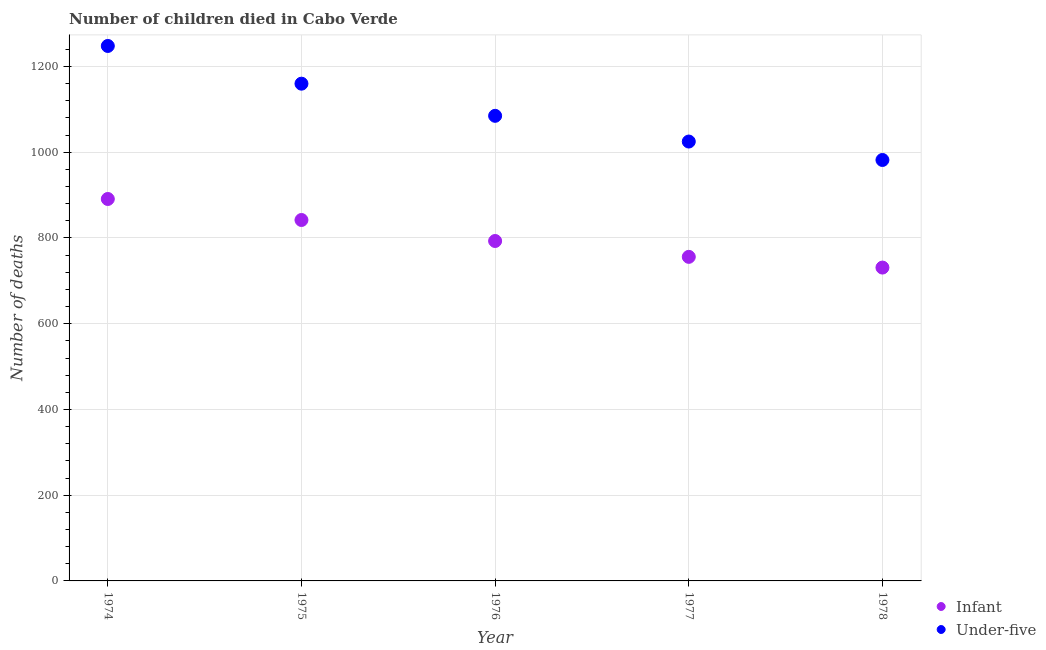How many different coloured dotlines are there?
Make the answer very short. 2. Is the number of dotlines equal to the number of legend labels?
Make the answer very short. Yes. What is the number of under-five deaths in 1976?
Give a very brief answer. 1085. Across all years, what is the maximum number of infant deaths?
Keep it short and to the point. 891. Across all years, what is the minimum number of under-five deaths?
Give a very brief answer. 982. In which year was the number of infant deaths maximum?
Ensure brevity in your answer.  1974. In which year was the number of under-five deaths minimum?
Give a very brief answer. 1978. What is the total number of infant deaths in the graph?
Provide a succinct answer. 4013. What is the difference between the number of infant deaths in 1975 and that in 1976?
Ensure brevity in your answer.  49. What is the difference between the number of under-five deaths in 1978 and the number of infant deaths in 1976?
Make the answer very short. 189. What is the average number of under-five deaths per year?
Give a very brief answer. 1100. In the year 1975, what is the difference between the number of infant deaths and number of under-five deaths?
Offer a terse response. -318. What is the ratio of the number of under-five deaths in 1975 to that in 1978?
Make the answer very short. 1.18. What is the difference between the highest and the second highest number of infant deaths?
Offer a very short reply. 49. What is the difference between the highest and the lowest number of infant deaths?
Offer a very short reply. 160. Does the number of infant deaths monotonically increase over the years?
Your response must be concise. No. Is the number of under-five deaths strictly greater than the number of infant deaths over the years?
Provide a short and direct response. Yes. How many dotlines are there?
Ensure brevity in your answer.  2. How many years are there in the graph?
Your answer should be compact. 5. What is the difference between two consecutive major ticks on the Y-axis?
Ensure brevity in your answer.  200. Are the values on the major ticks of Y-axis written in scientific E-notation?
Give a very brief answer. No. Does the graph contain any zero values?
Make the answer very short. No. Does the graph contain grids?
Offer a terse response. Yes. What is the title of the graph?
Provide a short and direct response. Number of children died in Cabo Verde. What is the label or title of the Y-axis?
Make the answer very short. Number of deaths. What is the Number of deaths of Infant in 1974?
Offer a terse response. 891. What is the Number of deaths of Under-five in 1974?
Your answer should be compact. 1248. What is the Number of deaths in Infant in 1975?
Ensure brevity in your answer.  842. What is the Number of deaths in Under-five in 1975?
Ensure brevity in your answer.  1160. What is the Number of deaths in Infant in 1976?
Your answer should be compact. 793. What is the Number of deaths of Under-five in 1976?
Provide a succinct answer. 1085. What is the Number of deaths in Infant in 1977?
Keep it short and to the point. 756. What is the Number of deaths of Under-five in 1977?
Your answer should be very brief. 1025. What is the Number of deaths of Infant in 1978?
Offer a terse response. 731. What is the Number of deaths of Under-five in 1978?
Make the answer very short. 982. Across all years, what is the maximum Number of deaths in Infant?
Your response must be concise. 891. Across all years, what is the maximum Number of deaths in Under-five?
Your answer should be very brief. 1248. Across all years, what is the minimum Number of deaths in Infant?
Keep it short and to the point. 731. Across all years, what is the minimum Number of deaths of Under-five?
Your answer should be compact. 982. What is the total Number of deaths of Infant in the graph?
Keep it short and to the point. 4013. What is the total Number of deaths of Under-five in the graph?
Provide a succinct answer. 5500. What is the difference between the Number of deaths of Under-five in 1974 and that in 1975?
Ensure brevity in your answer.  88. What is the difference between the Number of deaths of Under-five in 1974 and that in 1976?
Your answer should be compact. 163. What is the difference between the Number of deaths in Infant in 1974 and that in 1977?
Provide a short and direct response. 135. What is the difference between the Number of deaths of Under-five in 1974 and that in 1977?
Your answer should be compact. 223. What is the difference between the Number of deaths in Infant in 1974 and that in 1978?
Keep it short and to the point. 160. What is the difference between the Number of deaths in Under-five in 1974 and that in 1978?
Keep it short and to the point. 266. What is the difference between the Number of deaths in Infant in 1975 and that in 1976?
Ensure brevity in your answer.  49. What is the difference between the Number of deaths of Infant in 1975 and that in 1977?
Provide a short and direct response. 86. What is the difference between the Number of deaths in Under-five in 1975 and that in 1977?
Give a very brief answer. 135. What is the difference between the Number of deaths in Infant in 1975 and that in 1978?
Your answer should be compact. 111. What is the difference between the Number of deaths in Under-five in 1975 and that in 1978?
Your answer should be very brief. 178. What is the difference between the Number of deaths of Infant in 1976 and that in 1977?
Offer a very short reply. 37. What is the difference between the Number of deaths in Under-five in 1976 and that in 1978?
Your response must be concise. 103. What is the difference between the Number of deaths in Infant in 1977 and that in 1978?
Your answer should be compact. 25. What is the difference between the Number of deaths in Infant in 1974 and the Number of deaths in Under-five in 1975?
Your answer should be compact. -269. What is the difference between the Number of deaths of Infant in 1974 and the Number of deaths of Under-five in 1976?
Provide a short and direct response. -194. What is the difference between the Number of deaths in Infant in 1974 and the Number of deaths in Under-five in 1977?
Your response must be concise. -134. What is the difference between the Number of deaths in Infant in 1974 and the Number of deaths in Under-five in 1978?
Make the answer very short. -91. What is the difference between the Number of deaths of Infant in 1975 and the Number of deaths of Under-five in 1976?
Offer a terse response. -243. What is the difference between the Number of deaths in Infant in 1975 and the Number of deaths in Under-five in 1977?
Offer a very short reply. -183. What is the difference between the Number of deaths in Infant in 1975 and the Number of deaths in Under-five in 1978?
Offer a terse response. -140. What is the difference between the Number of deaths of Infant in 1976 and the Number of deaths of Under-five in 1977?
Provide a short and direct response. -232. What is the difference between the Number of deaths in Infant in 1976 and the Number of deaths in Under-five in 1978?
Offer a very short reply. -189. What is the difference between the Number of deaths of Infant in 1977 and the Number of deaths of Under-five in 1978?
Keep it short and to the point. -226. What is the average Number of deaths in Infant per year?
Give a very brief answer. 802.6. What is the average Number of deaths of Under-five per year?
Your response must be concise. 1100. In the year 1974, what is the difference between the Number of deaths of Infant and Number of deaths of Under-five?
Your answer should be compact. -357. In the year 1975, what is the difference between the Number of deaths in Infant and Number of deaths in Under-five?
Ensure brevity in your answer.  -318. In the year 1976, what is the difference between the Number of deaths in Infant and Number of deaths in Under-five?
Give a very brief answer. -292. In the year 1977, what is the difference between the Number of deaths in Infant and Number of deaths in Under-five?
Offer a terse response. -269. In the year 1978, what is the difference between the Number of deaths in Infant and Number of deaths in Under-five?
Make the answer very short. -251. What is the ratio of the Number of deaths of Infant in 1974 to that in 1975?
Offer a terse response. 1.06. What is the ratio of the Number of deaths in Under-five in 1974 to that in 1975?
Provide a short and direct response. 1.08. What is the ratio of the Number of deaths of Infant in 1974 to that in 1976?
Provide a short and direct response. 1.12. What is the ratio of the Number of deaths in Under-five in 1974 to that in 1976?
Give a very brief answer. 1.15. What is the ratio of the Number of deaths of Infant in 1974 to that in 1977?
Ensure brevity in your answer.  1.18. What is the ratio of the Number of deaths of Under-five in 1974 to that in 1977?
Provide a short and direct response. 1.22. What is the ratio of the Number of deaths of Infant in 1974 to that in 1978?
Your response must be concise. 1.22. What is the ratio of the Number of deaths of Under-five in 1974 to that in 1978?
Your answer should be very brief. 1.27. What is the ratio of the Number of deaths in Infant in 1975 to that in 1976?
Give a very brief answer. 1.06. What is the ratio of the Number of deaths in Under-five in 1975 to that in 1976?
Provide a succinct answer. 1.07. What is the ratio of the Number of deaths of Infant in 1975 to that in 1977?
Make the answer very short. 1.11. What is the ratio of the Number of deaths of Under-five in 1975 to that in 1977?
Make the answer very short. 1.13. What is the ratio of the Number of deaths in Infant in 1975 to that in 1978?
Your answer should be compact. 1.15. What is the ratio of the Number of deaths of Under-five in 1975 to that in 1978?
Keep it short and to the point. 1.18. What is the ratio of the Number of deaths in Infant in 1976 to that in 1977?
Provide a short and direct response. 1.05. What is the ratio of the Number of deaths in Under-five in 1976 to that in 1977?
Keep it short and to the point. 1.06. What is the ratio of the Number of deaths in Infant in 1976 to that in 1978?
Provide a succinct answer. 1.08. What is the ratio of the Number of deaths of Under-five in 1976 to that in 1978?
Provide a short and direct response. 1.1. What is the ratio of the Number of deaths of Infant in 1977 to that in 1978?
Keep it short and to the point. 1.03. What is the ratio of the Number of deaths in Under-five in 1977 to that in 1978?
Give a very brief answer. 1.04. What is the difference between the highest and the second highest Number of deaths in Under-five?
Your response must be concise. 88. What is the difference between the highest and the lowest Number of deaths in Infant?
Keep it short and to the point. 160. What is the difference between the highest and the lowest Number of deaths in Under-five?
Offer a terse response. 266. 